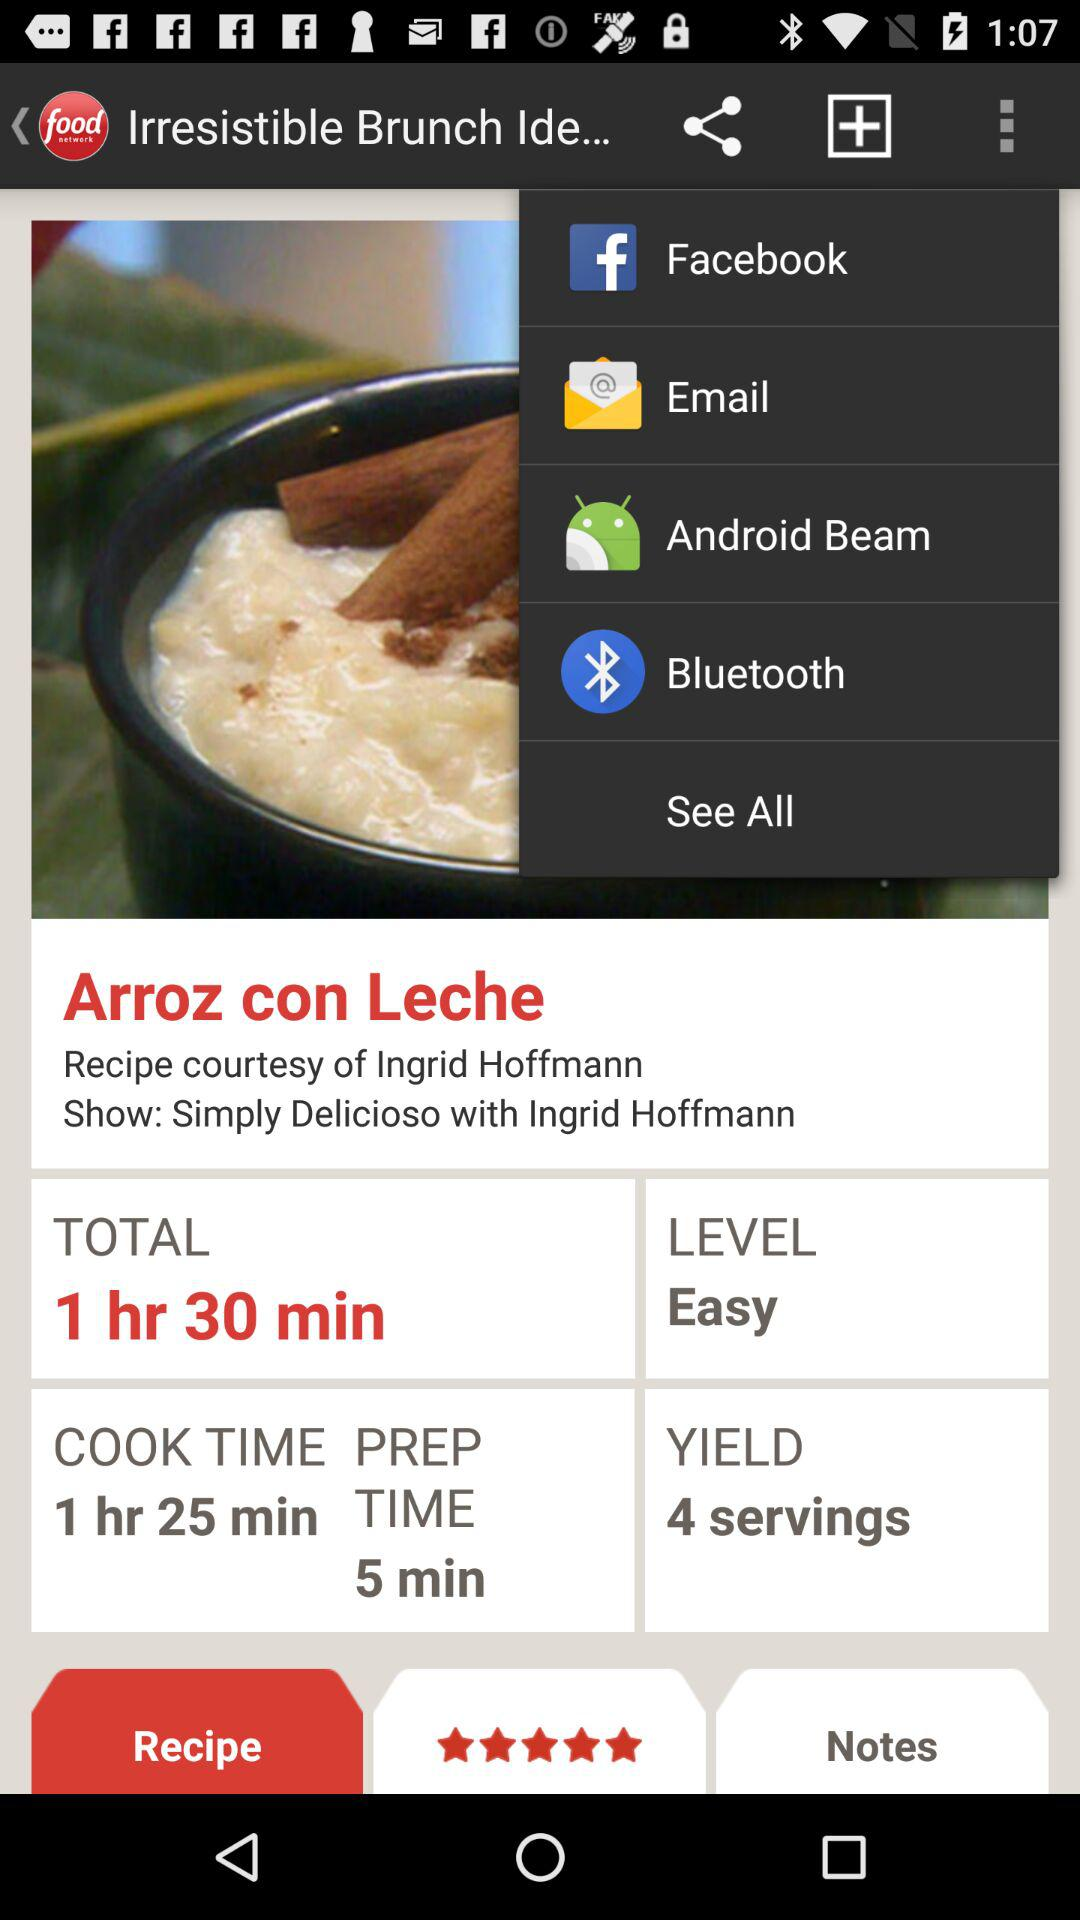What is the total time? The total time is 1 hour 30 minutes. 